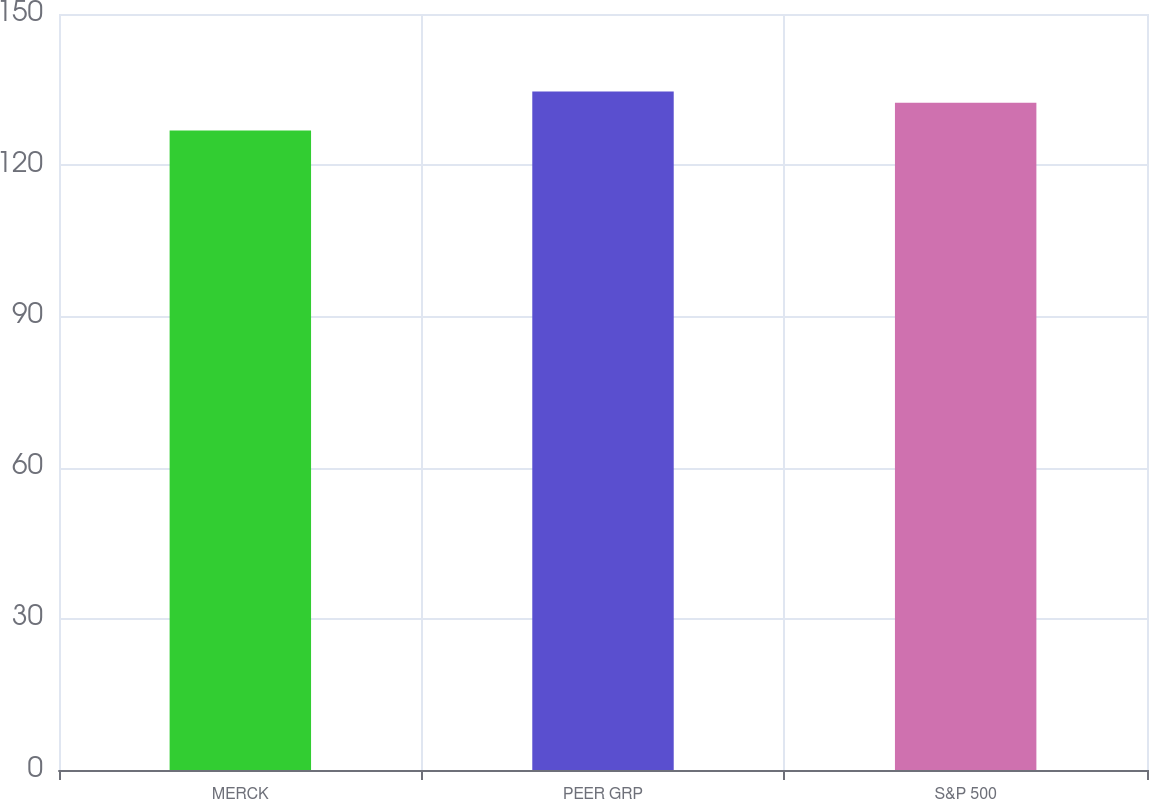<chart> <loc_0><loc_0><loc_500><loc_500><bar_chart><fcel>MERCK<fcel>PEER GRP<fcel>S&P 500<nl><fcel>126.9<fcel>134.6<fcel>132.4<nl></chart> 